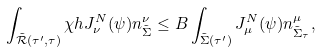<formula> <loc_0><loc_0><loc_500><loc_500>\int _ { \tilde { \mathcal { R } } ( \tau ^ { \prime } , \tau ) } \chi h J ^ { N } _ { \nu } ( \psi ) n ^ { \nu } _ { \tilde { \Sigma } } \leq B \int _ { \tilde { \Sigma } ( \tau ^ { \prime } ) } J ^ { N } _ { \mu } ( \psi ) n ^ { \mu } _ { \tilde { \Sigma } _ { \tau } } ,</formula> 